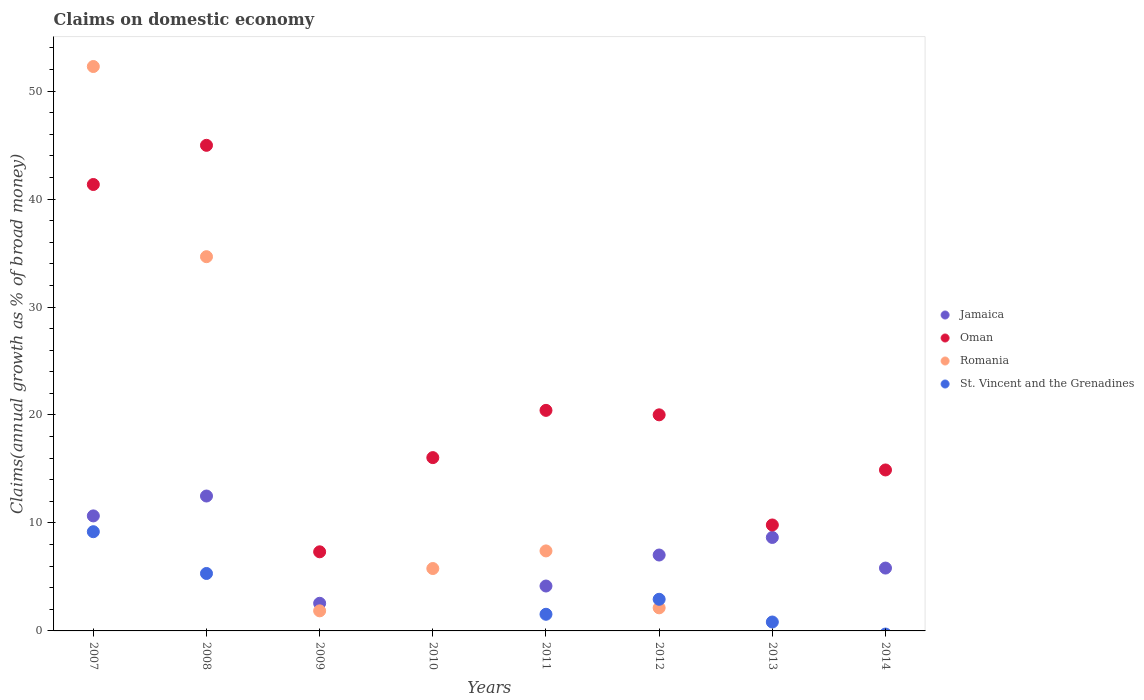What is the percentage of broad money claimed on domestic economy in Jamaica in 2013?
Provide a short and direct response. 8.66. Across all years, what is the maximum percentage of broad money claimed on domestic economy in Jamaica?
Provide a short and direct response. 12.49. Across all years, what is the minimum percentage of broad money claimed on domestic economy in St. Vincent and the Grenadines?
Offer a very short reply. 0. What is the total percentage of broad money claimed on domestic economy in Oman in the graph?
Your response must be concise. 174.87. What is the difference between the percentage of broad money claimed on domestic economy in Oman in 2009 and that in 2011?
Keep it short and to the point. -13.1. What is the difference between the percentage of broad money claimed on domestic economy in St. Vincent and the Grenadines in 2013 and the percentage of broad money claimed on domestic economy in Jamaica in 2009?
Offer a very short reply. -1.73. What is the average percentage of broad money claimed on domestic economy in Oman per year?
Ensure brevity in your answer.  21.86. In the year 2008, what is the difference between the percentage of broad money claimed on domestic economy in Romania and percentage of broad money claimed on domestic economy in Oman?
Keep it short and to the point. -10.31. What is the ratio of the percentage of broad money claimed on domestic economy in Jamaica in 2008 to that in 2014?
Ensure brevity in your answer.  2.15. Is the percentage of broad money claimed on domestic economy in Oman in 2007 less than that in 2011?
Provide a succinct answer. No. Is the difference between the percentage of broad money claimed on domestic economy in Romania in 2008 and 2012 greater than the difference between the percentage of broad money claimed on domestic economy in Oman in 2008 and 2012?
Your answer should be compact. Yes. What is the difference between the highest and the second highest percentage of broad money claimed on domestic economy in Jamaica?
Keep it short and to the point. 1.84. What is the difference between the highest and the lowest percentage of broad money claimed on domestic economy in Jamaica?
Give a very brief answer. 12.49. Does the percentage of broad money claimed on domestic economy in Oman monotonically increase over the years?
Keep it short and to the point. No. Is the percentage of broad money claimed on domestic economy in St. Vincent and the Grenadines strictly less than the percentage of broad money claimed on domestic economy in Oman over the years?
Your answer should be compact. Yes. How many dotlines are there?
Offer a terse response. 4. How many years are there in the graph?
Ensure brevity in your answer.  8. What is the difference between two consecutive major ticks on the Y-axis?
Give a very brief answer. 10. Are the values on the major ticks of Y-axis written in scientific E-notation?
Your answer should be compact. No. Does the graph contain any zero values?
Ensure brevity in your answer.  Yes. Does the graph contain grids?
Keep it short and to the point. No. How are the legend labels stacked?
Offer a very short reply. Vertical. What is the title of the graph?
Your response must be concise. Claims on domestic economy. What is the label or title of the X-axis?
Offer a terse response. Years. What is the label or title of the Y-axis?
Offer a terse response. Claims(annual growth as % of broad money). What is the Claims(annual growth as % of broad money) in Jamaica in 2007?
Your answer should be compact. 10.65. What is the Claims(annual growth as % of broad money) of Oman in 2007?
Your answer should be compact. 41.35. What is the Claims(annual growth as % of broad money) in Romania in 2007?
Provide a short and direct response. 52.28. What is the Claims(annual growth as % of broad money) in St. Vincent and the Grenadines in 2007?
Provide a succinct answer. 9.19. What is the Claims(annual growth as % of broad money) of Jamaica in 2008?
Offer a very short reply. 12.49. What is the Claims(annual growth as % of broad money) of Oman in 2008?
Give a very brief answer. 44.98. What is the Claims(annual growth as % of broad money) in Romania in 2008?
Provide a short and direct response. 34.66. What is the Claims(annual growth as % of broad money) in St. Vincent and the Grenadines in 2008?
Keep it short and to the point. 5.32. What is the Claims(annual growth as % of broad money) of Jamaica in 2009?
Ensure brevity in your answer.  2.56. What is the Claims(annual growth as % of broad money) in Oman in 2009?
Offer a very short reply. 7.33. What is the Claims(annual growth as % of broad money) of Romania in 2009?
Provide a short and direct response. 1.86. What is the Claims(annual growth as % of broad money) in St. Vincent and the Grenadines in 2009?
Offer a terse response. 0. What is the Claims(annual growth as % of broad money) in Oman in 2010?
Provide a succinct answer. 16.05. What is the Claims(annual growth as % of broad money) of Romania in 2010?
Your response must be concise. 5.78. What is the Claims(annual growth as % of broad money) of Jamaica in 2011?
Make the answer very short. 4.16. What is the Claims(annual growth as % of broad money) in Oman in 2011?
Your answer should be compact. 20.43. What is the Claims(annual growth as % of broad money) in Romania in 2011?
Provide a short and direct response. 7.41. What is the Claims(annual growth as % of broad money) of St. Vincent and the Grenadines in 2011?
Your answer should be compact. 1.54. What is the Claims(annual growth as % of broad money) of Jamaica in 2012?
Offer a terse response. 7.03. What is the Claims(annual growth as % of broad money) of Oman in 2012?
Your answer should be compact. 20.01. What is the Claims(annual growth as % of broad money) in Romania in 2012?
Keep it short and to the point. 2.14. What is the Claims(annual growth as % of broad money) in St. Vincent and the Grenadines in 2012?
Ensure brevity in your answer.  2.93. What is the Claims(annual growth as % of broad money) in Jamaica in 2013?
Your response must be concise. 8.66. What is the Claims(annual growth as % of broad money) in Oman in 2013?
Keep it short and to the point. 9.81. What is the Claims(annual growth as % of broad money) in Romania in 2013?
Provide a succinct answer. 0. What is the Claims(annual growth as % of broad money) of St. Vincent and the Grenadines in 2013?
Your response must be concise. 0.82. What is the Claims(annual growth as % of broad money) in Jamaica in 2014?
Your answer should be very brief. 5.82. What is the Claims(annual growth as % of broad money) in Oman in 2014?
Ensure brevity in your answer.  14.91. What is the Claims(annual growth as % of broad money) in Romania in 2014?
Give a very brief answer. 0. Across all years, what is the maximum Claims(annual growth as % of broad money) in Jamaica?
Your answer should be very brief. 12.49. Across all years, what is the maximum Claims(annual growth as % of broad money) of Oman?
Provide a succinct answer. 44.98. Across all years, what is the maximum Claims(annual growth as % of broad money) of Romania?
Provide a succinct answer. 52.28. Across all years, what is the maximum Claims(annual growth as % of broad money) in St. Vincent and the Grenadines?
Provide a short and direct response. 9.19. Across all years, what is the minimum Claims(annual growth as % of broad money) in Jamaica?
Provide a succinct answer. 0. Across all years, what is the minimum Claims(annual growth as % of broad money) in Oman?
Make the answer very short. 7.33. Across all years, what is the minimum Claims(annual growth as % of broad money) in St. Vincent and the Grenadines?
Provide a succinct answer. 0. What is the total Claims(annual growth as % of broad money) in Jamaica in the graph?
Your answer should be very brief. 51.38. What is the total Claims(annual growth as % of broad money) in Oman in the graph?
Offer a very short reply. 174.87. What is the total Claims(annual growth as % of broad money) of Romania in the graph?
Keep it short and to the point. 104.12. What is the total Claims(annual growth as % of broad money) in St. Vincent and the Grenadines in the graph?
Offer a terse response. 19.81. What is the difference between the Claims(annual growth as % of broad money) in Jamaica in 2007 and that in 2008?
Your answer should be very brief. -1.84. What is the difference between the Claims(annual growth as % of broad money) of Oman in 2007 and that in 2008?
Offer a very short reply. -3.63. What is the difference between the Claims(annual growth as % of broad money) of Romania in 2007 and that in 2008?
Your answer should be very brief. 17.61. What is the difference between the Claims(annual growth as % of broad money) of St. Vincent and the Grenadines in 2007 and that in 2008?
Provide a short and direct response. 3.87. What is the difference between the Claims(annual growth as % of broad money) of Jamaica in 2007 and that in 2009?
Make the answer very short. 8.09. What is the difference between the Claims(annual growth as % of broad money) of Oman in 2007 and that in 2009?
Make the answer very short. 34.02. What is the difference between the Claims(annual growth as % of broad money) of Romania in 2007 and that in 2009?
Provide a short and direct response. 50.42. What is the difference between the Claims(annual growth as % of broad money) of Oman in 2007 and that in 2010?
Make the answer very short. 25.3. What is the difference between the Claims(annual growth as % of broad money) in Romania in 2007 and that in 2010?
Offer a terse response. 46.5. What is the difference between the Claims(annual growth as % of broad money) of Jamaica in 2007 and that in 2011?
Your response must be concise. 6.49. What is the difference between the Claims(annual growth as % of broad money) of Oman in 2007 and that in 2011?
Your answer should be compact. 20.92. What is the difference between the Claims(annual growth as % of broad money) in Romania in 2007 and that in 2011?
Your answer should be very brief. 44.87. What is the difference between the Claims(annual growth as % of broad money) of St. Vincent and the Grenadines in 2007 and that in 2011?
Offer a very short reply. 7.65. What is the difference between the Claims(annual growth as % of broad money) in Jamaica in 2007 and that in 2012?
Your response must be concise. 3.62. What is the difference between the Claims(annual growth as % of broad money) in Oman in 2007 and that in 2012?
Keep it short and to the point. 21.33. What is the difference between the Claims(annual growth as % of broad money) in Romania in 2007 and that in 2012?
Give a very brief answer. 50.14. What is the difference between the Claims(annual growth as % of broad money) of St. Vincent and the Grenadines in 2007 and that in 2012?
Offer a very short reply. 6.26. What is the difference between the Claims(annual growth as % of broad money) in Jamaica in 2007 and that in 2013?
Provide a succinct answer. 2. What is the difference between the Claims(annual growth as % of broad money) in Oman in 2007 and that in 2013?
Make the answer very short. 31.53. What is the difference between the Claims(annual growth as % of broad money) of St. Vincent and the Grenadines in 2007 and that in 2013?
Ensure brevity in your answer.  8.36. What is the difference between the Claims(annual growth as % of broad money) in Jamaica in 2007 and that in 2014?
Keep it short and to the point. 4.83. What is the difference between the Claims(annual growth as % of broad money) of Oman in 2007 and that in 2014?
Keep it short and to the point. 26.44. What is the difference between the Claims(annual growth as % of broad money) of Jamaica in 2008 and that in 2009?
Your response must be concise. 9.93. What is the difference between the Claims(annual growth as % of broad money) in Oman in 2008 and that in 2009?
Your answer should be compact. 37.65. What is the difference between the Claims(annual growth as % of broad money) in Romania in 2008 and that in 2009?
Give a very brief answer. 32.8. What is the difference between the Claims(annual growth as % of broad money) of Oman in 2008 and that in 2010?
Your answer should be compact. 28.92. What is the difference between the Claims(annual growth as % of broad money) in Romania in 2008 and that in 2010?
Make the answer very short. 28.88. What is the difference between the Claims(annual growth as % of broad money) in Jamaica in 2008 and that in 2011?
Give a very brief answer. 8.34. What is the difference between the Claims(annual growth as % of broad money) of Oman in 2008 and that in 2011?
Give a very brief answer. 24.55. What is the difference between the Claims(annual growth as % of broad money) of Romania in 2008 and that in 2011?
Make the answer very short. 27.25. What is the difference between the Claims(annual growth as % of broad money) in St. Vincent and the Grenadines in 2008 and that in 2011?
Your answer should be very brief. 3.78. What is the difference between the Claims(annual growth as % of broad money) of Jamaica in 2008 and that in 2012?
Provide a short and direct response. 5.46. What is the difference between the Claims(annual growth as % of broad money) of Oman in 2008 and that in 2012?
Keep it short and to the point. 24.96. What is the difference between the Claims(annual growth as % of broad money) of Romania in 2008 and that in 2012?
Your response must be concise. 32.52. What is the difference between the Claims(annual growth as % of broad money) in St. Vincent and the Grenadines in 2008 and that in 2012?
Offer a very short reply. 2.39. What is the difference between the Claims(annual growth as % of broad money) in Jamaica in 2008 and that in 2013?
Your answer should be very brief. 3.84. What is the difference between the Claims(annual growth as % of broad money) of Oman in 2008 and that in 2013?
Your answer should be compact. 35.16. What is the difference between the Claims(annual growth as % of broad money) in St. Vincent and the Grenadines in 2008 and that in 2013?
Offer a very short reply. 4.5. What is the difference between the Claims(annual growth as % of broad money) of Jamaica in 2008 and that in 2014?
Keep it short and to the point. 6.67. What is the difference between the Claims(annual growth as % of broad money) in Oman in 2008 and that in 2014?
Keep it short and to the point. 30.07. What is the difference between the Claims(annual growth as % of broad money) in Oman in 2009 and that in 2010?
Offer a terse response. -8.72. What is the difference between the Claims(annual growth as % of broad money) of Romania in 2009 and that in 2010?
Make the answer very short. -3.92. What is the difference between the Claims(annual growth as % of broad money) in Jamaica in 2009 and that in 2011?
Offer a very short reply. -1.6. What is the difference between the Claims(annual growth as % of broad money) in Oman in 2009 and that in 2011?
Your response must be concise. -13.1. What is the difference between the Claims(annual growth as % of broad money) in Romania in 2009 and that in 2011?
Provide a short and direct response. -5.55. What is the difference between the Claims(annual growth as % of broad money) in Jamaica in 2009 and that in 2012?
Your answer should be compact. -4.47. What is the difference between the Claims(annual growth as % of broad money) in Oman in 2009 and that in 2012?
Your answer should be very brief. -12.69. What is the difference between the Claims(annual growth as % of broad money) in Romania in 2009 and that in 2012?
Your answer should be compact. -0.28. What is the difference between the Claims(annual growth as % of broad money) of Jamaica in 2009 and that in 2013?
Provide a succinct answer. -6.1. What is the difference between the Claims(annual growth as % of broad money) in Oman in 2009 and that in 2013?
Your answer should be compact. -2.49. What is the difference between the Claims(annual growth as % of broad money) of Jamaica in 2009 and that in 2014?
Your response must be concise. -3.26. What is the difference between the Claims(annual growth as % of broad money) in Oman in 2009 and that in 2014?
Your answer should be very brief. -7.58. What is the difference between the Claims(annual growth as % of broad money) in Oman in 2010 and that in 2011?
Make the answer very short. -4.38. What is the difference between the Claims(annual growth as % of broad money) of Romania in 2010 and that in 2011?
Your answer should be very brief. -1.63. What is the difference between the Claims(annual growth as % of broad money) in Oman in 2010 and that in 2012?
Ensure brevity in your answer.  -3.96. What is the difference between the Claims(annual growth as % of broad money) of Romania in 2010 and that in 2012?
Provide a short and direct response. 3.64. What is the difference between the Claims(annual growth as % of broad money) in Oman in 2010 and that in 2013?
Your answer should be compact. 6.24. What is the difference between the Claims(annual growth as % of broad money) of Oman in 2010 and that in 2014?
Your answer should be compact. 1.14. What is the difference between the Claims(annual growth as % of broad money) in Jamaica in 2011 and that in 2012?
Keep it short and to the point. -2.87. What is the difference between the Claims(annual growth as % of broad money) in Oman in 2011 and that in 2012?
Make the answer very short. 0.41. What is the difference between the Claims(annual growth as % of broad money) in Romania in 2011 and that in 2012?
Your answer should be very brief. 5.27. What is the difference between the Claims(annual growth as % of broad money) of St. Vincent and the Grenadines in 2011 and that in 2012?
Give a very brief answer. -1.39. What is the difference between the Claims(annual growth as % of broad money) of Jamaica in 2011 and that in 2013?
Make the answer very short. -4.5. What is the difference between the Claims(annual growth as % of broad money) in Oman in 2011 and that in 2013?
Offer a very short reply. 10.62. What is the difference between the Claims(annual growth as % of broad money) of St. Vincent and the Grenadines in 2011 and that in 2013?
Your answer should be compact. 0.72. What is the difference between the Claims(annual growth as % of broad money) of Jamaica in 2011 and that in 2014?
Provide a succinct answer. -1.66. What is the difference between the Claims(annual growth as % of broad money) in Oman in 2011 and that in 2014?
Offer a very short reply. 5.52. What is the difference between the Claims(annual growth as % of broad money) of Jamaica in 2012 and that in 2013?
Offer a very short reply. -1.63. What is the difference between the Claims(annual growth as % of broad money) in Oman in 2012 and that in 2013?
Give a very brief answer. 10.2. What is the difference between the Claims(annual growth as % of broad money) in St. Vincent and the Grenadines in 2012 and that in 2013?
Provide a succinct answer. 2.11. What is the difference between the Claims(annual growth as % of broad money) of Jamaica in 2012 and that in 2014?
Keep it short and to the point. 1.21. What is the difference between the Claims(annual growth as % of broad money) in Oman in 2012 and that in 2014?
Offer a very short reply. 5.11. What is the difference between the Claims(annual growth as % of broad money) in Jamaica in 2013 and that in 2014?
Give a very brief answer. 2.84. What is the difference between the Claims(annual growth as % of broad money) in Oman in 2013 and that in 2014?
Ensure brevity in your answer.  -5.1. What is the difference between the Claims(annual growth as % of broad money) of Jamaica in 2007 and the Claims(annual growth as % of broad money) of Oman in 2008?
Give a very brief answer. -34.32. What is the difference between the Claims(annual growth as % of broad money) of Jamaica in 2007 and the Claims(annual growth as % of broad money) of Romania in 2008?
Keep it short and to the point. -24.01. What is the difference between the Claims(annual growth as % of broad money) in Jamaica in 2007 and the Claims(annual growth as % of broad money) in St. Vincent and the Grenadines in 2008?
Provide a succinct answer. 5.33. What is the difference between the Claims(annual growth as % of broad money) of Oman in 2007 and the Claims(annual growth as % of broad money) of Romania in 2008?
Offer a very short reply. 6.69. What is the difference between the Claims(annual growth as % of broad money) in Oman in 2007 and the Claims(annual growth as % of broad money) in St. Vincent and the Grenadines in 2008?
Give a very brief answer. 36.03. What is the difference between the Claims(annual growth as % of broad money) of Romania in 2007 and the Claims(annual growth as % of broad money) of St. Vincent and the Grenadines in 2008?
Your answer should be very brief. 46.95. What is the difference between the Claims(annual growth as % of broad money) of Jamaica in 2007 and the Claims(annual growth as % of broad money) of Oman in 2009?
Your answer should be compact. 3.33. What is the difference between the Claims(annual growth as % of broad money) in Jamaica in 2007 and the Claims(annual growth as % of broad money) in Romania in 2009?
Your answer should be very brief. 8.79. What is the difference between the Claims(annual growth as % of broad money) in Oman in 2007 and the Claims(annual growth as % of broad money) in Romania in 2009?
Your answer should be very brief. 39.49. What is the difference between the Claims(annual growth as % of broad money) of Jamaica in 2007 and the Claims(annual growth as % of broad money) of Oman in 2010?
Your answer should be compact. -5.4. What is the difference between the Claims(annual growth as % of broad money) in Jamaica in 2007 and the Claims(annual growth as % of broad money) in Romania in 2010?
Offer a very short reply. 4.87. What is the difference between the Claims(annual growth as % of broad money) in Oman in 2007 and the Claims(annual growth as % of broad money) in Romania in 2010?
Provide a succinct answer. 35.57. What is the difference between the Claims(annual growth as % of broad money) of Jamaica in 2007 and the Claims(annual growth as % of broad money) of Oman in 2011?
Give a very brief answer. -9.77. What is the difference between the Claims(annual growth as % of broad money) of Jamaica in 2007 and the Claims(annual growth as % of broad money) of Romania in 2011?
Make the answer very short. 3.24. What is the difference between the Claims(annual growth as % of broad money) in Jamaica in 2007 and the Claims(annual growth as % of broad money) in St. Vincent and the Grenadines in 2011?
Provide a succinct answer. 9.11. What is the difference between the Claims(annual growth as % of broad money) in Oman in 2007 and the Claims(annual growth as % of broad money) in Romania in 2011?
Provide a short and direct response. 33.94. What is the difference between the Claims(annual growth as % of broad money) in Oman in 2007 and the Claims(annual growth as % of broad money) in St. Vincent and the Grenadines in 2011?
Offer a very short reply. 39.8. What is the difference between the Claims(annual growth as % of broad money) of Romania in 2007 and the Claims(annual growth as % of broad money) of St. Vincent and the Grenadines in 2011?
Provide a short and direct response. 50.73. What is the difference between the Claims(annual growth as % of broad money) of Jamaica in 2007 and the Claims(annual growth as % of broad money) of Oman in 2012?
Ensure brevity in your answer.  -9.36. What is the difference between the Claims(annual growth as % of broad money) in Jamaica in 2007 and the Claims(annual growth as % of broad money) in Romania in 2012?
Your response must be concise. 8.52. What is the difference between the Claims(annual growth as % of broad money) in Jamaica in 2007 and the Claims(annual growth as % of broad money) in St. Vincent and the Grenadines in 2012?
Your answer should be very brief. 7.72. What is the difference between the Claims(annual growth as % of broad money) in Oman in 2007 and the Claims(annual growth as % of broad money) in Romania in 2012?
Offer a very short reply. 39.21. What is the difference between the Claims(annual growth as % of broad money) of Oman in 2007 and the Claims(annual growth as % of broad money) of St. Vincent and the Grenadines in 2012?
Offer a terse response. 38.42. What is the difference between the Claims(annual growth as % of broad money) in Romania in 2007 and the Claims(annual growth as % of broad money) in St. Vincent and the Grenadines in 2012?
Offer a terse response. 49.34. What is the difference between the Claims(annual growth as % of broad money) of Jamaica in 2007 and the Claims(annual growth as % of broad money) of Oman in 2013?
Provide a short and direct response. 0.84. What is the difference between the Claims(annual growth as % of broad money) in Jamaica in 2007 and the Claims(annual growth as % of broad money) in St. Vincent and the Grenadines in 2013?
Provide a short and direct response. 9.83. What is the difference between the Claims(annual growth as % of broad money) in Oman in 2007 and the Claims(annual growth as % of broad money) in St. Vincent and the Grenadines in 2013?
Offer a very short reply. 40.52. What is the difference between the Claims(annual growth as % of broad money) in Romania in 2007 and the Claims(annual growth as % of broad money) in St. Vincent and the Grenadines in 2013?
Your response must be concise. 51.45. What is the difference between the Claims(annual growth as % of broad money) of Jamaica in 2007 and the Claims(annual growth as % of broad money) of Oman in 2014?
Give a very brief answer. -4.25. What is the difference between the Claims(annual growth as % of broad money) of Jamaica in 2008 and the Claims(annual growth as % of broad money) of Oman in 2009?
Your answer should be very brief. 5.17. What is the difference between the Claims(annual growth as % of broad money) in Jamaica in 2008 and the Claims(annual growth as % of broad money) in Romania in 2009?
Your answer should be very brief. 10.64. What is the difference between the Claims(annual growth as % of broad money) in Oman in 2008 and the Claims(annual growth as % of broad money) in Romania in 2009?
Your answer should be very brief. 43.12. What is the difference between the Claims(annual growth as % of broad money) of Jamaica in 2008 and the Claims(annual growth as % of broad money) of Oman in 2010?
Your answer should be very brief. -3.56. What is the difference between the Claims(annual growth as % of broad money) of Jamaica in 2008 and the Claims(annual growth as % of broad money) of Romania in 2010?
Ensure brevity in your answer.  6.72. What is the difference between the Claims(annual growth as % of broad money) of Oman in 2008 and the Claims(annual growth as % of broad money) of Romania in 2010?
Provide a succinct answer. 39.2. What is the difference between the Claims(annual growth as % of broad money) in Jamaica in 2008 and the Claims(annual growth as % of broad money) in Oman in 2011?
Offer a very short reply. -7.93. What is the difference between the Claims(annual growth as % of broad money) in Jamaica in 2008 and the Claims(annual growth as % of broad money) in Romania in 2011?
Give a very brief answer. 5.08. What is the difference between the Claims(annual growth as % of broad money) of Jamaica in 2008 and the Claims(annual growth as % of broad money) of St. Vincent and the Grenadines in 2011?
Offer a terse response. 10.95. What is the difference between the Claims(annual growth as % of broad money) in Oman in 2008 and the Claims(annual growth as % of broad money) in Romania in 2011?
Ensure brevity in your answer.  37.57. What is the difference between the Claims(annual growth as % of broad money) of Oman in 2008 and the Claims(annual growth as % of broad money) of St. Vincent and the Grenadines in 2011?
Ensure brevity in your answer.  43.43. What is the difference between the Claims(annual growth as % of broad money) of Romania in 2008 and the Claims(annual growth as % of broad money) of St. Vincent and the Grenadines in 2011?
Your answer should be very brief. 33.12. What is the difference between the Claims(annual growth as % of broad money) of Jamaica in 2008 and the Claims(annual growth as % of broad money) of Oman in 2012?
Provide a succinct answer. -7.52. What is the difference between the Claims(annual growth as % of broad money) in Jamaica in 2008 and the Claims(annual growth as % of broad money) in Romania in 2012?
Your answer should be compact. 10.36. What is the difference between the Claims(annual growth as % of broad money) in Jamaica in 2008 and the Claims(annual growth as % of broad money) in St. Vincent and the Grenadines in 2012?
Offer a terse response. 9.56. What is the difference between the Claims(annual growth as % of broad money) of Oman in 2008 and the Claims(annual growth as % of broad money) of Romania in 2012?
Ensure brevity in your answer.  42.84. What is the difference between the Claims(annual growth as % of broad money) in Oman in 2008 and the Claims(annual growth as % of broad money) in St. Vincent and the Grenadines in 2012?
Ensure brevity in your answer.  42.05. What is the difference between the Claims(annual growth as % of broad money) in Romania in 2008 and the Claims(annual growth as % of broad money) in St. Vincent and the Grenadines in 2012?
Offer a very short reply. 31.73. What is the difference between the Claims(annual growth as % of broad money) in Jamaica in 2008 and the Claims(annual growth as % of broad money) in Oman in 2013?
Your answer should be compact. 2.68. What is the difference between the Claims(annual growth as % of broad money) in Jamaica in 2008 and the Claims(annual growth as % of broad money) in St. Vincent and the Grenadines in 2013?
Your answer should be very brief. 11.67. What is the difference between the Claims(annual growth as % of broad money) in Oman in 2008 and the Claims(annual growth as % of broad money) in St. Vincent and the Grenadines in 2013?
Your response must be concise. 44.15. What is the difference between the Claims(annual growth as % of broad money) in Romania in 2008 and the Claims(annual growth as % of broad money) in St. Vincent and the Grenadines in 2013?
Your answer should be very brief. 33.84. What is the difference between the Claims(annual growth as % of broad money) of Jamaica in 2008 and the Claims(annual growth as % of broad money) of Oman in 2014?
Provide a succinct answer. -2.41. What is the difference between the Claims(annual growth as % of broad money) of Jamaica in 2009 and the Claims(annual growth as % of broad money) of Oman in 2010?
Provide a short and direct response. -13.49. What is the difference between the Claims(annual growth as % of broad money) of Jamaica in 2009 and the Claims(annual growth as % of broad money) of Romania in 2010?
Your response must be concise. -3.22. What is the difference between the Claims(annual growth as % of broad money) of Oman in 2009 and the Claims(annual growth as % of broad money) of Romania in 2010?
Keep it short and to the point. 1.55. What is the difference between the Claims(annual growth as % of broad money) in Jamaica in 2009 and the Claims(annual growth as % of broad money) in Oman in 2011?
Provide a succinct answer. -17.87. What is the difference between the Claims(annual growth as % of broad money) in Jamaica in 2009 and the Claims(annual growth as % of broad money) in Romania in 2011?
Keep it short and to the point. -4.85. What is the difference between the Claims(annual growth as % of broad money) in Jamaica in 2009 and the Claims(annual growth as % of broad money) in St. Vincent and the Grenadines in 2011?
Your response must be concise. 1.02. What is the difference between the Claims(annual growth as % of broad money) of Oman in 2009 and the Claims(annual growth as % of broad money) of Romania in 2011?
Offer a terse response. -0.08. What is the difference between the Claims(annual growth as % of broad money) in Oman in 2009 and the Claims(annual growth as % of broad money) in St. Vincent and the Grenadines in 2011?
Provide a succinct answer. 5.78. What is the difference between the Claims(annual growth as % of broad money) in Romania in 2009 and the Claims(annual growth as % of broad money) in St. Vincent and the Grenadines in 2011?
Your answer should be compact. 0.32. What is the difference between the Claims(annual growth as % of broad money) of Jamaica in 2009 and the Claims(annual growth as % of broad money) of Oman in 2012?
Keep it short and to the point. -17.45. What is the difference between the Claims(annual growth as % of broad money) in Jamaica in 2009 and the Claims(annual growth as % of broad money) in Romania in 2012?
Your answer should be compact. 0.42. What is the difference between the Claims(annual growth as % of broad money) in Jamaica in 2009 and the Claims(annual growth as % of broad money) in St. Vincent and the Grenadines in 2012?
Provide a short and direct response. -0.37. What is the difference between the Claims(annual growth as % of broad money) in Oman in 2009 and the Claims(annual growth as % of broad money) in Romania in 2012?
Your answer should be very brief. 5.19. What is the difference between the Claims(annual growth as % of broad money) in Oman in 2009 and the Claims(annual growth as % of broad money) in St. Vincent and the Grenadines in 2012?
Provide a short and direct response. 4.4. What is the difference between the Claims(annual growth as % of broad money) in Romania in 2009 and the Claims(annual growth as % of broad money) in St. Vincent and the Grenadines in 2012?
Your answer should be compact. -1.07. What is the difference between the Claims(annual growth as % of broad money) of Jamaica in 2009 and the Claims(annual growth as % of broad money) of Oman in 2013?
Your answer should be very brief. -7.25. What is the difference between the Claims(annual growth as % of broad money) of Jamaica in 2009 and the Claims(annual growth as % of broad money) of St. Vincent and the Grenadines in 2013?
Ensure brevity in your answer.  1.73. What is the difference between the Claims(annual growth as % of broad money) in Oman in 2009 and the Claims(annual growth as % of broad money) in St. Vincent and the Grenadines in 2013?
Your response must be concise. 6.5. What is the difference between the Claims(annual growth as % of broad money) in Romania in 2009 and the Claims(annual growth as % of broad money) in St. Vincent and the Grenadines in 2013?
Your answer should be compact. 1.03. What is the difference between the Claims(annual growth as % of broad money) of Jamaica in 2009 and the Claims(annual growth as % of broad money) of Oman in 2014?
Keep it short and to the point. -12.35. What is the difference between the Claims(annual growth as % of broad money) in Oman in 2010 and the Claims(annual growth as % of broad money) in Romania in 2011?
Give a very brief answer. 8.64. What is the difference between the Claims(annual growth as % of broad money) in Oman in 2010 and the Claims(annual growth as % of broad money) in St. Vincent and the Grenadines in 2011?
Offer a terse response. 14.51. What is the difference between the Claims(annual growth as % of broad money) in Romania in 2010 and the Claims(annual growth as % of broad money) in St. Vincent and the Grenadines in 2011?
Offer a very short reply. 4.24. What is the difference between the Claims(annual growth as % of broad money) of Oman in 2010 and the Claims(annual growth as % of broad money) of Romania in 2012?
Your answer should be very brief. 13.91. What is the difference between the Claims(annual growth as % of broad money) of Oman in 2010 and the Claims(annual growth as % of broad money) of St. Vincent and the Grenadines in 2012?
Your answer should be very brief. 13.12. What is the difference between the Claims(annual growth as % of broad money) in Romania in 2010 and the Claims(annual growth as % of broad money) in St. Vincent and the Grenadines in 2012?
Your response must be concise. 2.85. What is the difference between the Claims(annual growth as % of broad money) in Oman in 2010 and the Claims(annual growth as % of broad money) in St. Vincent and the Grenadines in 2013?
Keep it short and to the point. 15.23. What is the difference between the Claims(annual growth as % of broad money) in Romania in 2010 and the Claims(annual growth as % of broad money) in St. Vincent and the Grenadines in 2013?
Give a very brief answer. 4.95. What is the difference between the Claims(annual growth as % of broad money) in Jamaica in 2011 and the Claims(annual growth as % of broad money) in Oman in 2012?
Give a very brief answer. -15.86. What is the difference between the Claims(annual growth as % of broad money) in Jamaica in 2011 and the Claims(annual growth as % of broad money) in Romania in 2012?
Provide a short and direct response. 2.02. What is the difference between the Claims(annual growth as % of broad money) in Jamaica in 2011 and the Claims(annual growth as % of broad money) in St. Vincent and the Grenadines in 2012?
Offer a very short reply. 1.23. What is the difference between the Claims(annual growth as % of broad money) of Oman in 2011 and the Claims(annual growth as % of broad money) of Romania in 2012?
Offer a very short reply. 18.29. What is the difference between the Claims(annual growth as % of broad money) in Oman in 2011 and the Claims(annual growth as % of broad money) in St. Vincent and the Grenadines in 2012?
Your answer should be very brief. 17.5. What is the difference between the Claims(annual growth as % of broad money) of Romania in 2011 and the Claims(annual growth as % of broad money) of St. Vincent and the Grenadines in 2012?
Provide a succinct answer. 4.48. What is the difference between the Claims(annual growth as % of broad money) of Jamaica in 2011 and the Claims(annual growth as % of broad money) of Oman in 2013?
Provide a short and direct response. -5.65. What is the difference between the Claims(annual growth as % of broad money) in Jamaica in 2011 and the Claims(annual growth as % of broad money) in St. Vincent and the Grenadines in 2013?
Your answer should be compact. 3.33. What is the difference between the Claims(annual growth as % of broad money) in Oman in 2011 and the Claims(annual growth as % of broad money) in St. Vincent and the Grenadines in 2013?
Keep it short and to the point. 19.6. What is the difference between the Claims(annual growth as % of broad money) of Romania in 2011 and the Claims(annual growth as % of broad money) of St. Vincent and the Grenadines in 2013?
Your answer should be compact. 6.58. What is the difference between the Claims(annual growth as % of broad money) of Jamaica in 2011 and the Claims(annual growth as % of broad money) of Oman in 2014?
Offer a very short reply. -10.75. What is the difference between the Claims(annual growth as % of broad money) in Jamaica in 2012 and the Claims(annual growth as % of broad money) in Oman in 2013?
Your answer should be very brief. -2.78. What is the difference between the Claims(annual growth as % of broad money) of Jamaica in 2012 and the Claims(annual growth as % of broad money) of St. Vincent and the Grenadines in 2013?
Offer a very short reply. 6.2. What is the difference between the Claims(annual growth as % of broad money) in Oman in 2012 and the Claims(annual growth as % of broad money) in St. Vincent and the Grenadines in 2013?
Make the answer very short. 19.19. What is the difference between the Claims(annual growth as % of broad money) of Romania in 2012 and the Claims(annual growth as % of broad money) of St. Vincent and the Grenadines in 2013?
Make the answer very short. 1.31. What is the difference between the Claims(annual growth as % of broad money) of Jamaica in 2012 and the Claims(annual growth as % of broad money) of Oman in 2014?
Your answer should be compact. -7.88. What is the difference between the Claims(annual growth as % of broad money) in Jamaica in 2013 and the Claims(annual growth as % of broad money) in Oman in 2014?
Provide a succinct answer. -6.25. What is the average Claims(annual growth as % of broad money) in Jamaica per year?
Keep it short and to the point. 6.42. What is the average Claims(annual growth as % of broad money) in Oman per year?
Your response must be concise. 21.86. What is the average Claims(annual growth as % of broad money) in Romania per year?
Your answer should be compact. 13.02. What is the average Claims(annual growth as % of broad money) in St. Vincent and the Grenadines per year?
Give a very brief answer. 2.48. In the year 2007, what is the difference between the Claims(annual growth as % of broad money) in Jamaica and Claims(annual growth as % of broad money) in Oman?
Ensure brevity in your answer.  -30.69. In the year 2007, what is the difference between the Claims(annual growth as % of broad money) of Jamaica and Claims(annual growth as % of broad money) of Romania?
Offer a terse response. -41.62. In the year 2007, what is the difference between the Claims(annual growth as % of broad money) of Jamaica and Claims(annual growth as % of broad money) of St. Vincent and the Grenadines?
Your response must be concise. 1.46. In the year 2007, what is the difference between the Claims(annual growth as % of broad money) of Oman and Claims(annual growth as % of broad money) of Romania?
Keep it short and to the point. -10.93. In the year 2007, what is the difference between the Claims(annual growth as % of broad money) in Oman and Claims(annual growth as % of broad money) in St. Vincent and the Grenadines?
Make the answer very short. 32.16. In the year 2007, what is the difference between the Claims(annual growth as % of broad money) of Romania and Claims(annual growth as % of broad money) of St. Vincent and the Grenadines?
Your answer should be very brief. 43.09. In the year 2008, what is the difference between the Claims(annual growth as % of broad money) in Jamaica and Claims(annual growth as % of broad money) in Oman?
Keep it short and to the point. -32.48. In the year 2008, what is the difference between the Claims(annual growth as % of broad money) of Jamaica and Claims(annual growth as % of broad money) of Romania?
Offer a terse response. -22.17. In the year 2008, what is the difference between the Claims(annual growth as % of broad money) in Jamaica and Claims(annual growth as % of broad money) in St. Vincent and the Grenadines?
Give a very brief answer. 7.17. In the year 2008, what is the difference between the Claims(annual growth as % of broad money) of Oman and Claims(annual growth as % of broad money) of Romania?
Provide a succinct answer. 10.31. In the year 2008, what is the difference between the Claims(annual growth as % of broad money) of Oman and Claims(annual growth as % of broad money) of St. Vincent and the Grenadines?
Your response must be concise. 39.66. In the year 2008, what is the difference between the Claims(annual growth as % of broad money) in Romania and Claims(annual growth as % of broad money) in St. Vincent and the Grenadines?
Provide a short and direct response. 29.34. In the year 2009, what is the difference between the Claims(annual growth as % of broad money) of Jamaica and Claims(annual growth as % of broad money) of Oman?
Give a very brief answer. -4.77. In the year 2009, what is the difference between the Claims(annual growth as % of broad money) of Jamaica and Claims(annual growth as % of broad money) of Romania?
Keep it short and to the point. 0.7. In the year 2009, what is the difference between the Claims(annual growth as % of broad money) in Oman and Claims(annual growth as % of broad money) in Romania?
Provide a short and direct response. 5.47. In the year 2010, what is the difference between the Claims(annual growth as % of broad money) in Oman and Claims(annual growth as % of broad money) in Romania?
Ensure brevity in your answer.  10.27. In the year 2011, what is the difference between the Claims(annual growth as % of broad money) of Jamaica and Claims(annual growth as % of broad money) of Oman?
Offer a terse response. -16.27. In the year 2011, what is the difference between the Claims(annual growth as % of broad money) of Jamaica and Claims(annual growth as % of broad money) of Romania?
Provide a short and direct response. -3.25. In the year 2011, what is the difference between the Claims(annual growth as % of broad money) in Jamaica and Claims(annual growth as % of broad money) in St. Vincent and the Grenadines?
Give a very brief answer. 2.62. In the year 2011, what is the difference between the Claims(annual growth as % of broad money) of Oman and Claims(annual growth as % of broad money) of Romania?
Your answer should be compact. 13.02. In the year 2011, what is the difference between the Claims(annual growth as % of broad money) in Oman and Claims(annual growth as % of broad money) in St. Vincent and the Grenadines?
Offer a very short reply. 18.89. In the year 2011, what is the difference between the Claims(annual growth as % of broad money) in Romania and Claims(annual growth as % of broad money) in St. Vincent and the Grenadines?
Offer a very short reply. 5.87. In the year 2012, what is the difference between the Claims(annual growth as % of broad money) in Jamaica and Claims(annual growth as % of broad money) in Oman?
Your answer should be very brief. -12.98. In the year 2012, what is the difference between the Claims(annual growth as % of broad money) of Jamaica and Claims(annual growth as % of broad money) of Romania?
Keep it short and to the point. 4.89. In the year 2012, what is the difference between the Claims(annual growth as % of broad money) of Jamaica and Claims(annual growth as % of broad money) of St. Vincent and the Grenadines?
Your answer should be compact. 4.1. In the year 2012, what is the difference between the Claims(annual growth as % of broad money) of Oman and Claims(annual growth as % of broad money) of Romania?
Ensure brevity in your answer.  17.88. In the year 2012, what is the difference between the Claims(annual growth as % of broad money) of Oman and Claims(annual growth as % of broad money) of St. Vincent and the Grenadines?
Make the answer very short. 17.08. In the year 2012, what is the difference between the Claims(annual growth as % of broad money) of Romania and Claims(annual growth as % of broad money) of St. Vincent and the Grenadines?
Your answer should be very brief. -0.79. In the year 2013, what is the difference between the Claims(annual growth as % of broad money) of Jamaica and Claims(annual growth as % of broad money) of Oman?
Give a very brief answer. -1.16. In the year 2013, what is the difference between the Claims(annual growth as % of broad money) of Jamaica and Claims(annual growth as % of broad money) of St. Vincent and the Grenadines?
Your answer should be compact. 7.83. In the year 2013, what is the difference between the Claims(annual growth as % of broad money) of Oman and Claims(annual growth as % of broad money) of St. Vincent and the Grenadines?
Ensure brevity in your answer.  8.99. In the year 2014, what is the difference between the Claims(annual growth as % of broad money) of Jamaica and Claims(annual growth as % of broad money) of Oman?
Provide a short and direct response. -9.09. What is the ratio of the Claims(annual growth as % of broad money) in Jamaica in 2007 to that in 2008?
Your answer should be compact. 0.85. What is the ratio of the Claims(annual growth as % of broad money) in Oman in 2007 to that in 2008?
Your response must be concise. 0.92. What is the ratio of the Claims(annual growth as % of broad money) of Romania in 2007 to that in 2008?
Offer a very short reply. 1.51. What is the ratio of the Claims(annual growth as % of broad money) in St. Vincent and the Grenadines in 2007 to that in 2008?
Your answer should be compact. 1.73. What is the ratio of the Claims(annual growth as % of broad money) in Jamaica in 2007 to that in 2009?
Ensure brevity in your answer.  4.16. What is the ratio of the Claims(annual growth as % of broad money) of Oman in 2007 to that in 2009?
Your answer should be very brief. 5.64. What is the ratio of the Claims(annual growth as % of broad money) in Romania in 2007 to that in 2009?
Your answer should be compact. 28.12. What is the ratio of the Claims(annual growth as % of broad money) of Oman in 2007 to that in 2010?
Your answer should be compact. 2.58. What is the ratio of the Claims(annual growth as % of broad money) in Romania in 2007 to that in 2010?
Provide a short and direct response. 9.05. What is the ratio of the Claims(annual growth as % of broad money) of Jamaica in 2007 to that in 2011?
Your answer should be compact. 2.56. What is the ratio of the Claims(annual growth as % of broad money) of Oman in 2007 to that in 2011?
Provide a short and direct response. 2.02. What is the ratio of the Claims(annual growth as % of broad money) in Romania in 2007 to that in 2011?
Your answer should be very brief. 7.05. What is the ratio of the Claims(annual growth as % of broad money) in St. Vincent and the Grenadines in 2007 to that in 2011?
Your answer should be compact. 5.96. What is the ratio of the Claims(annual growth as % of broad money) in Jamaica in 2007 to that in 2012?
Give a very brief answer. 1.52. What is the ratio of the Claims(annual growth as % of broad money) in Oman in 2007 to that in 2012?
Ensure brevity in your answer.  2.07. What is the ratio of the Claims(annual growth as % of broad money) in Romania in 2007 to that in 2012?
Your response must be concise. 24.45. What is the ratio of the Claims(annual growth as % of broad money) in St. Vincent and the Grenadines in 2007 to that in 2012?
Your answer should be compact. 3.14. What is the ratio of the Claims(annual growth as % of broad money) of Jamaica in 2007 to that in 2013?
Provide a short and direct response. 1.23. What is the ratio of the Claims(annual growth as % of broad money) in Oman in 2007 to that in 2013?
Your answer should be very brief. 4.21. What is the ratio of the Claims(annual growth as % of broad money) in St. Vincent and the Grenadines in 2007 to that in 2013?
Offer a very short reply. 11.14. What is the ratio of the Claims(annual growth as % of broad money) in Jamaica in 2007 to that in 2014?
Offer a very short reply. 1.83. What is the ratio of the Claims(annual growth as % of broad money) in Oman in 2007 to that in 2014?
Your answer should be very brief. 2.77. What is the ratio of the Claims(annual growth as % of broad money) of Jamaica in 2008 to that in 2009?
Offer a very short reply. 4.88. What is the ratio of the Claims(annual growth as % of broad money) in Oman in 2008 to that in 2009?
Offer a terse response. 6.14. What is the ratio of the Claims(annual growth as % of broad money) in Romania in 2008 to that in 2009?
Offer a very short reply. 18.65. What is the ratio of the Claims(annual growth as % of broad money) of Oman in 2008 to that in 2010?
Your answer should be compact. 2.8. What is the ratio of the Claims(annual growth as % of broad money) of Romania in 2008 to that in 2010?
Keep it short and to the point. 6. What is the ratio of the Claims(annual growth as % of broad money) of Jamaica in 2008 to that in 2011?
Keep it short and to the point. 3. What is the ratio of the Claims(annual growth as % of broad money) in Oman in 2008 to that in 2011?
Provide a succinct answer. 2.2. What is the ratio of the Claims(annual growth as % of broad money) of Romania in 2008 to that in 2011?
Your answer should be very brief. 4.68. What is the ratio of the Claims(annual growth as % of broad money) in St. Vincent and the Grenadines in 2008 to that in 2011?
Offer a very short reply. 3.45. What is the ratio of the Claims(annual growth as % of broad money) of Jamaica in 2008 to that in 2012?
Your answer should be very brief. 1.78. What is the ratio of the Claims(annual growth as % of broad money) of Oman in 2008 to that in 2012?
Provide a succinct answer. 2.25. What is the ratio of the Claims(annual growth as % of broad money) of Romania in 2008 to that in 2012?
Your answer should be compact. 16.21. What is the ratio of the Claims(annual growth as % of broad money) in St. Vincent and the Grenadines in 2008 to that in 2012?
Offer a very short reply. 1.82. What is the ratio of the Claims(annual growth as % of broad money) of Jamaica in 2008 to that in 2013?
Provide a short and direct response. 1.44. What is the ratio of the Claims(annual growth as % of broad money) of Oman in 2008 to that in 2013?
Provide a succinct answer. 4.58. What is the ratio of the Claims(annual growth as % of broad money) in St. Vincent and the Grenadines in 2008 to that in 2013?
Make the answer very short. 6.45. What is the ratio of the Claims(annual growth as % of broad money) in Jamaica in 2008 to that in 2014?
Provide a succinct answer. 2.15. What is the ratio of the Claims(annual growth as % of broad money) of Oman in 2008 to that in 2014?
Provide a short and direct response. 3.02. What is the ratio of the Claims(annual growth as % of broad money) of Oman in 2009 to that in 2010?
Offer a terse response. 0.46. What is the ratio of the Claims(annual growth as % of broad money) in Romania in 2009 to that in 2010?
Offer a very short reply. 0.32. What is the ratio of the Claims(annual growth as % of broad money) in Jamaica in 2009 to that in 2011?
Offer a very short reply. 0.62. What is the ratio of the Claims(annual growth as % of broad money) of Oman in 2009 to that in 2011?
Offer a terse response. 0.36. What is the ratio of the Claims(annual growth as % of broad money) in Romania in 2009 to that in 2011?
Provide a short and direct response. 0.25. What is the ratio of the Claims(annual growth as % of broad money) in Jamaica in 2009 to that in 2012?
Your response must be concise. 0.36. What is the ratio of the Claims(annual growth as % of broad money) in Oman in 2009 to that in 2012?
Ensure brevity in your answer.  0.37. What is the ratio of the Claims(annual growth as % of broad money) in Romania in 2009 to that in 2012?
Ensure brevity in your answer.  0.87. What is the ratio of the Claims(annual growth as % of broad money) in Jamaica in 2009 to that in 2013?
Ensure brevity in your answer.  0.3. What is the ratio of the Claims(annual growth as % of broad money) of Oman in 2009 to that in 2013?
Your answer should be compact. 0.75. What is the ratio of the Claims(annual growth as % of broad money) in Jamaica in 2009 to that in 2014?
Your answer should be compact. 0.44. What is the ratio of the Claims(annual growth as % of broad money) in Oman in 2009 to that in 2014?
Your response must be concise. 0.49. What is the ratio of the Claims(annual growth as % of broad money) of Oman in 2010 to that in 2011?
Make the answer very short. 0.79. What is the ratio of the Claims(annual growth as % of broad money) of Romania in 2010 to that in 2011?
Make the answer very short. 0.78. What is the ratio of the Claims(annual growth as % of broad money) in Oman in 2010 to that in 2012?
Your answer should be very brief. 0.8. What is the ratio of the Claims(annual growth as % of broad money) in Romania in 2010 to that in 2012?
Your answer should be very brief. 2.7. What is the ratio of the Claims(annual growth as % of broad money) in Oman in 2010 to that in 2013?
Your response must be concise. 1.64. What is the ratio of the Claims(annual growth as % of broad money) in Oman in 2010 to that in 2014?
Provide a succinct answer. 1.08. What is the ratio of the Claims(annual growth as % of broad money) in Jamaica in 2011 to that in 2012?
Ensure brevity in your answer.  0.59. What is the ratio of the Claims(annual growth as % of broad money) in Oman in 2011 to that in 2012?
Make the answer very short. 1.02. What is the ratio of the Claims(annual growth as % of broad money) in Romania in 2011 to that in 2012?
Provide a short and direct response. 3.47. What is the ratio of the Claims(annual growth as % of broad money) of St. Vincent and the Grenadines in 2011 to that in 2012?
Give a very brief answer. 0.53. What is the ratio of the Claims(annual growth as % of broad money) in Jamaica in 2011 to that in 2013?
Provide a short and direct response. 0.48. What is the ratio of the Claims(annual growth as % of broad money) in Oman in 2011 to that in 2013?
Provide a short and direct response. 2.08. What is the ratio of the Claims(annual growth as % of broad money) in St. Vincent and the Grenadines in 2011 to that in 2013?
Your answer should be compact. 1.87. What is the ratio of the Claims(annual growth as % of broad money) of Jamaica in 2011 to that in 2014?
Ensure brevity in your answer.  0.71. What is the ratio of the Claims(annual growth as % of broad money) in Oman in 2011 to that in 2014?
Your answer should be very brief. 1.37. What is the ratio of the Claims(annual growth as % of broad money) of Jamaica in 2012 to that in 2013?
Keep it short and to the point. 0.81. What is the ratio of the Claims(annual growth as % of broad money) in Oman in 2012 to that in 2013?
Offer a terse response. 2.04. What is the ratio of the Claims(annual growth as % of broad money) in St. Vincent and the Grenadines in 2012 to that in 2013?
Offer a terse response. 3.55. What is the ratio of the Claims(annual growth as % of broad money) of Jamaica in 2012 to that in 2014?
Offer a terse response. 1.21. What is the ratio of the Claims(annual growth as % of broad money) in Oman in 2012 to that in 2014?
Offer a terse response. 1.34. What is the ratio of the Claims(annual growth as % of broad money) of Jamaica in 2013 to that in 2014?
Give a very brief answer. 1.49. What is the ratio of the Claims(annual growth as % of broad money) in Oman in 2013 to that in 2014?
Offer a very short reply. 0.66. What is the difference between the highest and the second highest Claims(annual growth as % of broad money) in Jamaica?
Your response must be concise. 1.84. What is the difference between the highest and the second highest Claims(annual growth as % of broad money) in Oman?
Offer a terse response. 3.63. What is the difference between the highest and the second highest Claims(annual growth as % of broad money) of Romania?
Your response must be concise. 17.61. What is the difference between the highest and the second highest Claims(annual growth as % of broad money) of St. Vincent and the Grenadines?
Offer a very short reply. 3.87. What is the difference between the highest and the lowest Claims(annual growth as % of broad money) of Jamaica?
Ensure brevity in your answer.  12.49. What is the difference between the highest and the lowest Claims(annual growth as % of broad money) of Oman?
Make the answer very short. 37.65. What is the difference between the highest and the lowest Claims(annual growth as % of broad money) of Romania?
Provide a succinct answer. 52.28. What is the difference between the highest and the lowest Claims(annual growth as % of broad money) in St. Vincent and the Grenadines?
Offer a terse response. 9.19. 